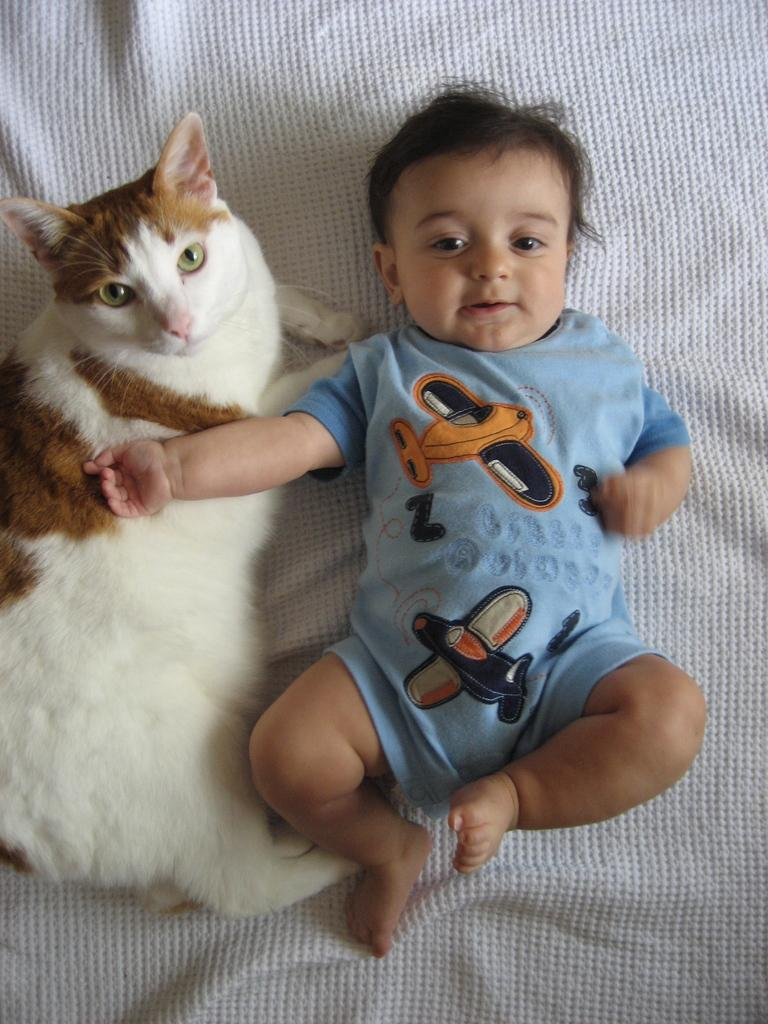Who is present in the image? There is a boy in the image. What type of animal can be seen in the image? There is a white color cat in the image. How many birds are flying in the image? There are no birds present in the image. What type of time-related information can be gathered from the image? The image does not provide any time-related information. 